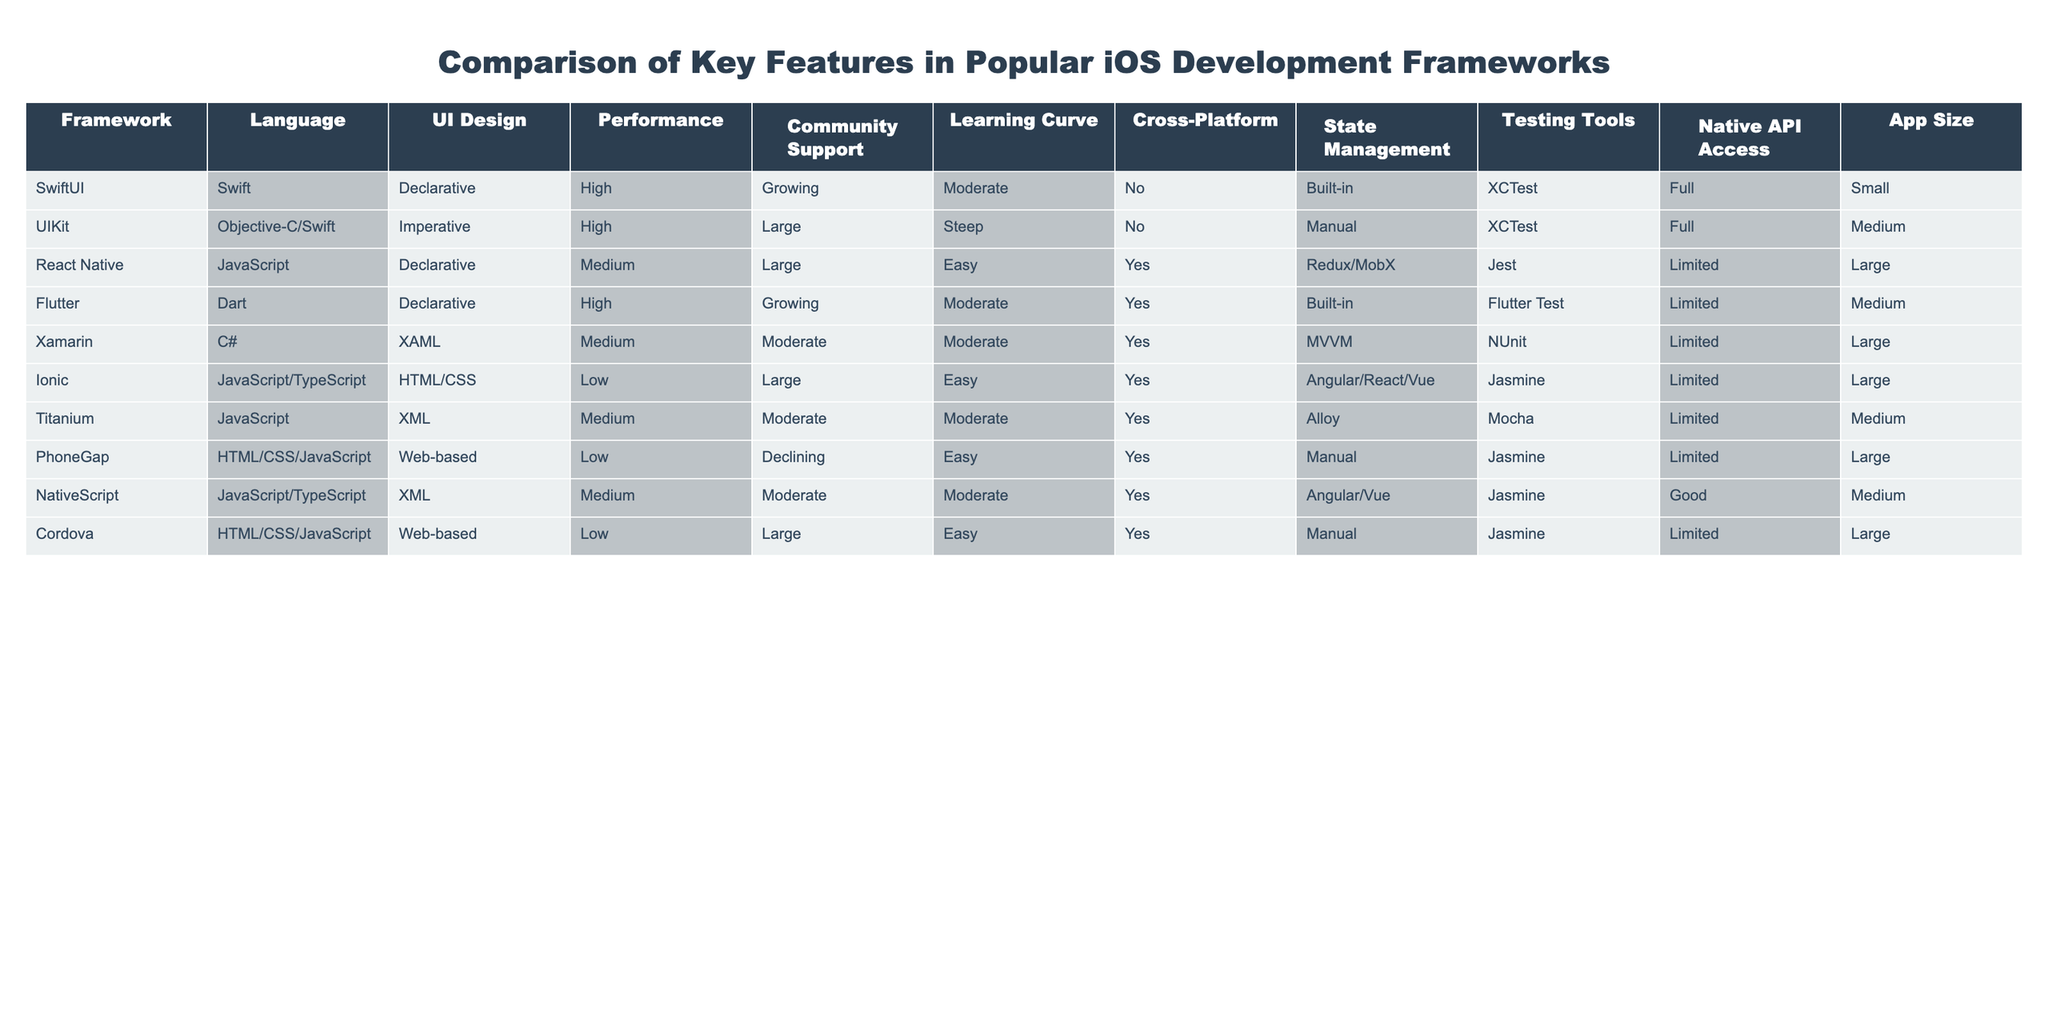What framework has the highest performance rating? The performance ratings are listed for each framework, and both SwiftUI and UIKit show a "High" rating. However, there is no data showing that SwiftUI has better performance than UIKit.
Answer: UIKit Which frameworks support cross-platform development? The table lists React Native, Flutter, Xamarin, Ionic, Titanium, PhoneGap, NativeScript, and Cordova as frameworks that support cross-platform development.
Answer: 8 frameworks Is SwiftUI the only framework using a declarative UI design? The table shows that SwiftUI, React Native, Flutter, and Ionic all use a declarative UI design, making SwiftUI not the only one.
Answer: No Which framework has the steepest learning curve? By examining the "Learning Curve" column, UIKit is marked as "Steep," which is the steepest compared to other frameworks.
Answer: UIKit What is the average app size of the frameworks with high performance? The frameworks with high performance (SwiftUI, UIKit, Flutter) have app sizes of Small (SwiftUI), Medium (UIKit), and Medium (Flutter). The average size is (1 + 2 + 2) / 3 = 1.67, which we approximate to Small.
Answer: Small Do all frameworks have full access to native APIs? Reviewing the "Native API Access" column indicates that SwiftUI and UIKit provide "Full" access, while others like React Native, Flutter, Xamarin, and others provide "Limited." Therefore, not all frameworks have full access.
Answer: No Which framework has the highest community support? Currently, UIKit has the highest community support labeled as "Large," while others are labeled as either "Growing" or "Moderate."
Answer: UIKit How many frameworks use JavaScript or TypeScript? Checking the "Framework" and "Language" columns, the frameworks using JavaScript or TypeScript are React Native, Ionic, Titanium, PhoneGap, NativeScript, and Cordova. This gives a total of six frameworks.
Answer: 6 frameworks Which framework has both easy learning curve and cross-platform capability? The "Learning Curve" column lists React Native, Ionic, and PhoneGap as "Easy," and the "Cross-Platform" column shows all three also support cross-platform development.
Answer: React Native, Ionic, PhoneGap Is there a framework with a low performance rating that offers a growing community support? The performance column indicates that Ionic and PhoneGap have a "Low" rating, and both are rated as "Declining" and "Easy," respectively, indicating they do not have growing support.
Answer: No 